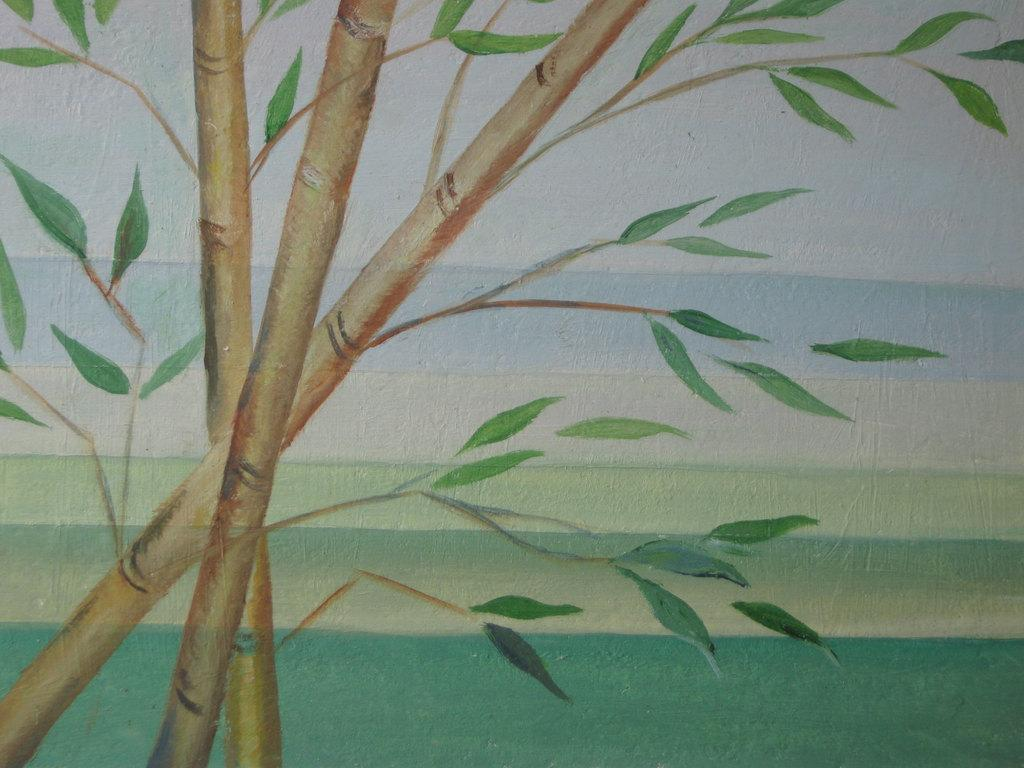What is the main subject of the image? There is a painting in the image. What is depicted in the painting? The painting depicts trees. What can be observed about the trees in the painting? The trees have leaves. What type of wire is used to create the painting in the image? There is no wire mentioned or visible in the image; the painting is created using a different medium, likely paint or digital art. 